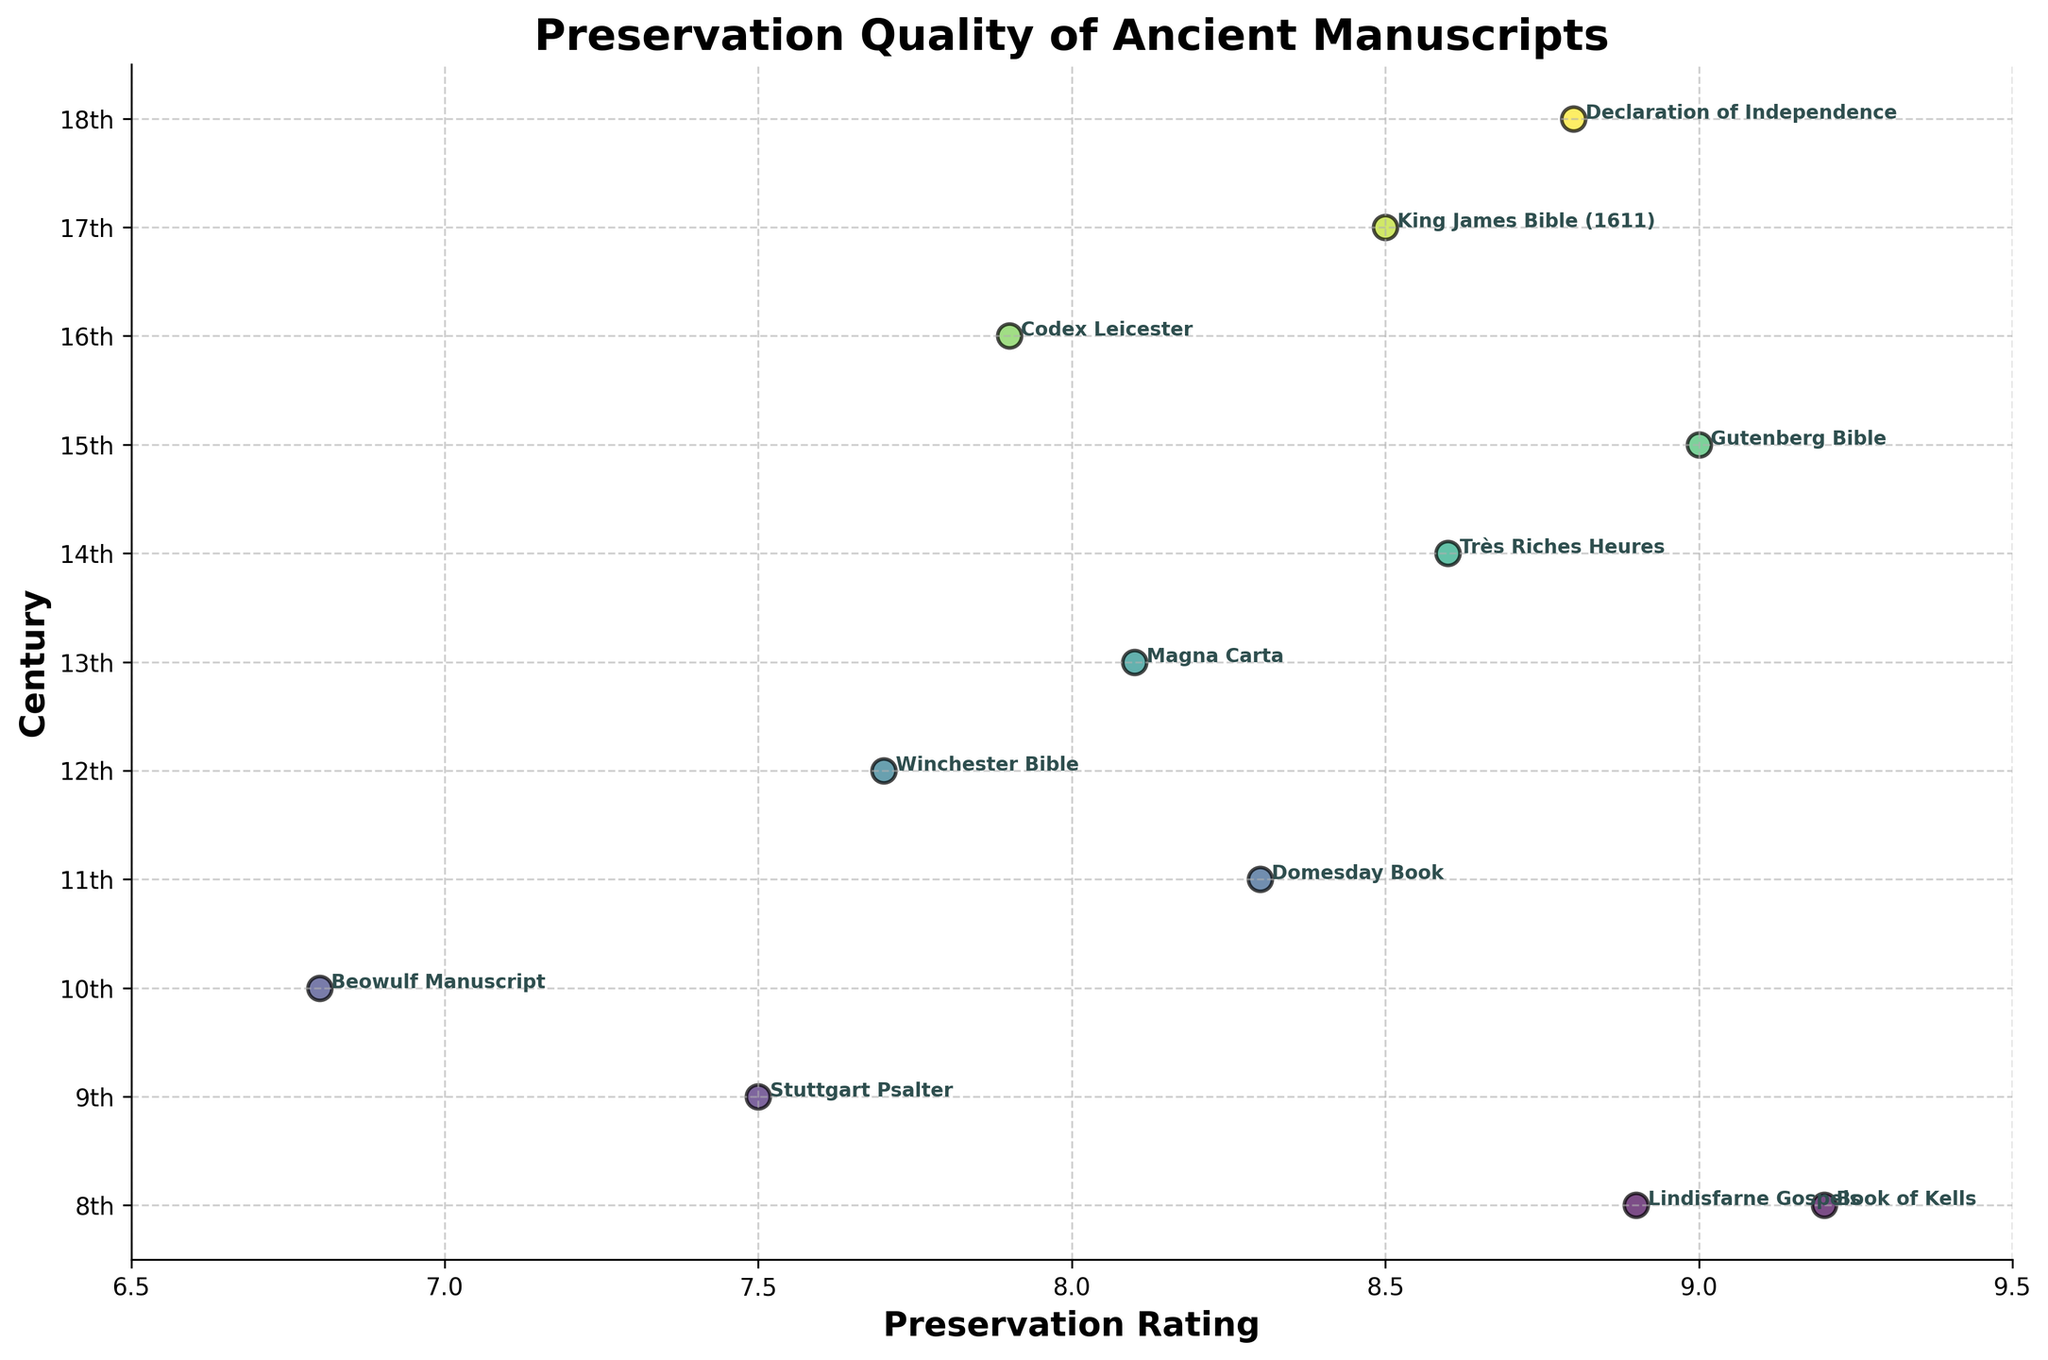What is the title of the figure? The title is usually located at the top of the figure. It provides a concise summary of the data being visualized.
Answer: Preservation Quality of Ancient Manuscripts Which manuscript has the highest preservation rating? Locate the highest point on the x-axis representing preservation ratings and find the associated manuscript label.
Answer: Book of Kells How many manuscripts are displayed from the 8th century? Count the number of points along the y-axis labeled "8th" century.
Answer: 2 What is the range of preservation ratings shown in the figure? Identify the minimum and maximum preservation ratings among all plotted points. The minimum is 6.8 (Beowulf Manuscript), and the maximum is 9.2 (Book of Kells). The range is 9.2 - 6.8.
Answer: 2.4 Compare the preservation ratings of manuscripts from the 9th and 12th centuries. Which century's manuscript has a higher rating? Locate the points on the x-axis for the 9th (Stuttgart Psalter, 7.5) and 12th (Winchester Bible, 7.7) centuries and compare their x-values.
Answer: 12th century Which centuries have a single manuscript displayed? Identify centuries with only one data point on the plot.
Answer: 9th, 10th, 11th, 12th, 13th, 14th, 15th, 16th, 17th, 18th What is the average preservation rating for manuscripts from the 8th century? Add the preservation ratings for the 8th-century manuscripts and divide by the number of manuscripts (9.2 + 8.9) / 2.
Answer: 9.05 Does the 17th century manuscript have a preservation rating higher than 8.5? Look at the preservation rating for the 17th century manuscript (King James Bible, 8.5).
Answer: No Identify the centuries where the preservation rating is above 8 for all manuscripts. Analyze each century's manuscripts' ratings and check if all points lie above 8 on the x-axis (8th, 11th, 13th, 14th, 15th, 17th, 18th centuries).
Answer: 8th, 11th, 13th, 14th, 15th, 17th, 18th Which manuscript from the 18th century is displayed and what is its preservation rating? Locate the data point on the y-axis labeled "18th" and read its corresponding x-axis value and manuscript label.
Answer: Declaration of Independence, 8.8 